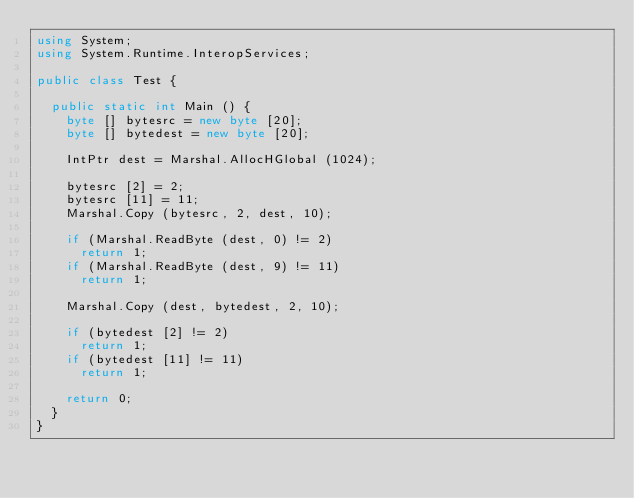<code> <loc_0><loc_0><loc_500><loc_500><_C#_>using System;
using System.Runtime.InteropServices;

public class Test {

	public static int Main () {
		byte [] bytesrc = new byte [20];
		byte [] bytedest = new byte [20];

		IntPtr dest = Marshal.AllocHGlobal (1024);
		
		bytesrc [2] = 2;
		bytesrc [11] = 11;		
		Marshal.Copy (bytesrc, 2, dest, 10);

		if (Marshal.ReadByte (dest, 0) != 2)
			return 1;
		if (Marshal.ReadByte (dest, 9) != 11)
			return 1;

		Marshal.Copy (dest, bytedest, 2, 10);

		if (bytedest [2] != 2)
			return 1;
		if (bytedest [11] != 11)
			return 1;		

		return 0;
	}
}

</code> 